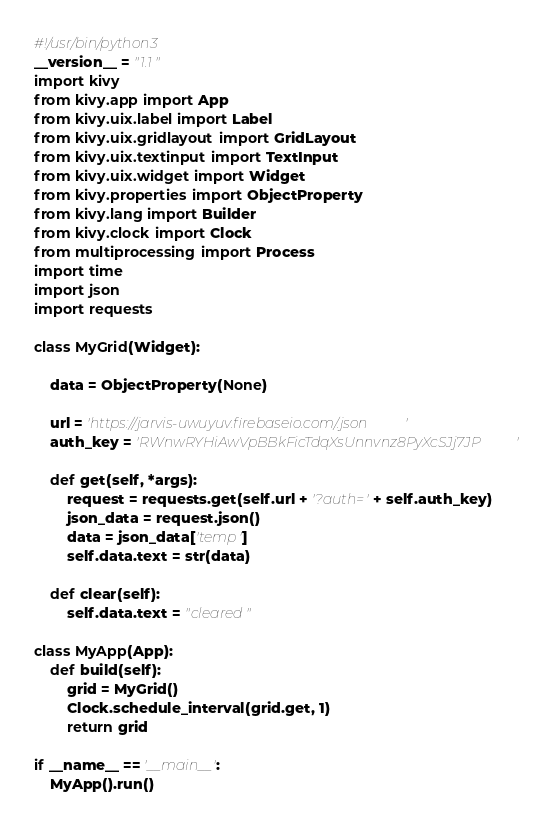Convert code to text. <code><loc_0><loc_0><loc_500><loc_500><_Python_>#!/usr/bin/python3
__version__ = "1.1"
import kivy
from kivy.app import App
from kivy.uix.label import Label
from kivy.uix.gridlayout import GridLayout
from kivy.uix.textinput import TextInput
from kivy.uix.widget import Widget
from kivy.properties import ObjectProperty
from kivy.lang import Builder
from kivy.clock import Clock
from multiprocessing import Process
import time
import json
import requests

class MyGrid(Widget):

    data = ObjectProperty(None)

    url = 'https://jarvis-uwuyuv.firebaseio.com/.json'
    auth_key = 'RWnwRYHiAwVpBBkFicTdqXsUnnvnz8PyXcSJj7JP'

    def get(self, *args):
        request = requests.get(self.url + '?auth=' + self.auth_key)
        json_data = request.json()
        data = json_data['temp']
        self.data.text = str(data)

    def clear(self):
        self.data.text = "cleared"

class MyApp(App):
    def build(self):
        grid = MyGrid()
        Clock.schedule_interval(grid.get, 1)
        return grid

if __name__ == '__main__':
    MyApp().run()</code> 